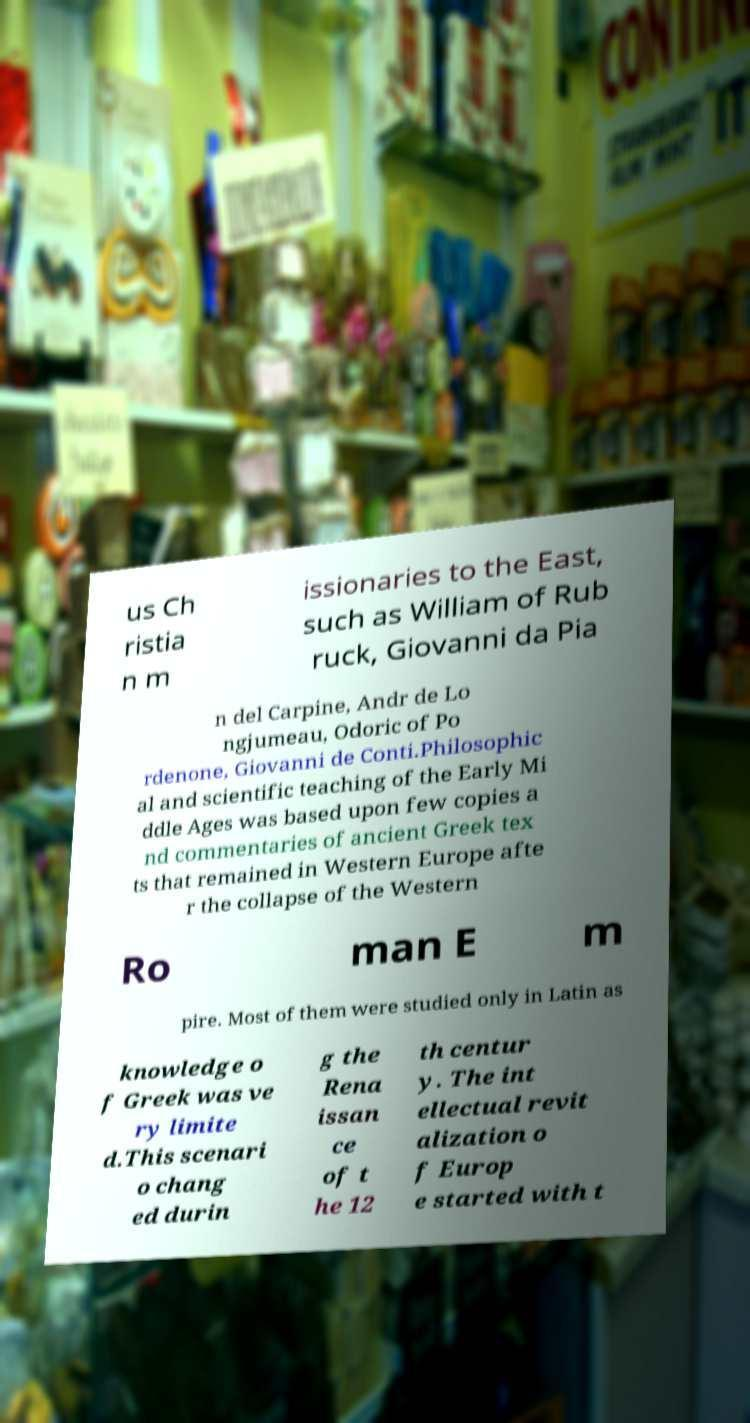Please read and relay the text visible in this image. What does it say? us Ch ristia n m issionaries to the East, such as William of Rub ruck, Giovanni da Pia n del Carpine, Andr de Lo ngjumeau, Odoric of Po rdenone, Giovanni de Conti.Philosophic al and scientific teaching of the Early Mi ddle Ages was based upon few copies a nd commentaries of ancient Greek tex ts that remained in Western Europe afte r the collapse of the Western Ro man E m pire. Most of them were studied only in Latin as knowledge o f Greek was ve ry limite d.This scenari o chang ed durin g the Rena issan ce of t he 12 th centur y. The int ellectual revit alization o f Europ e started with t 